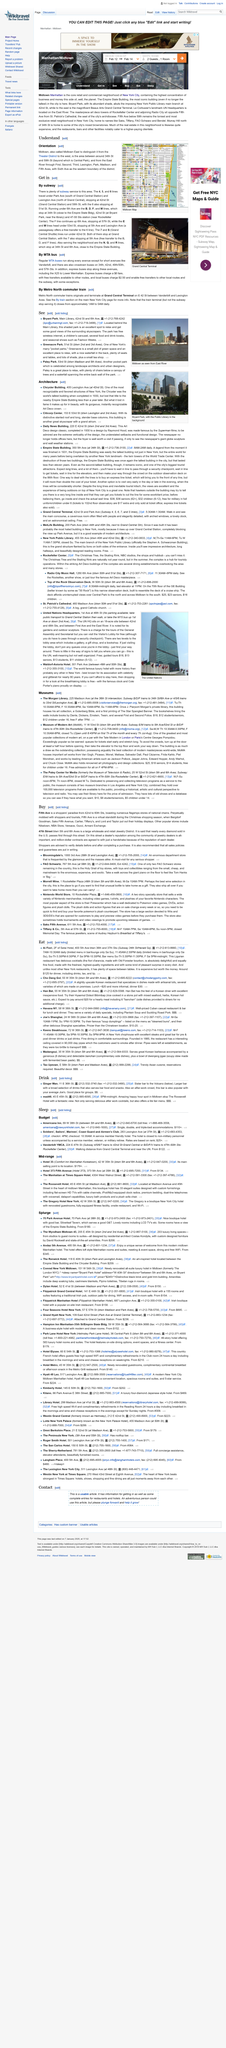Specify some key components in this picture. 47th Street is a thriving wholesale and retail Jewelry District that is known for its wide variety of jewelry options and its central location in the heart of New York City. It is widely known that 47th street plays a significant role in the diamond industry in the United States. It is claimed that nearly every diamond sold in the country passes through this street. The dates for the check-in and check-out of the core retail and commercial neighborhood of New York City are from February 12 to February 14. Le Corbusier's landmark United Nations Headquarters is located on the East River in New York City. Fifth Avenue is a shopper's paradise that stretches from 42nd to 60th Streets and features numerous flagship stores of national chains that offer an array of products and services to customers. 